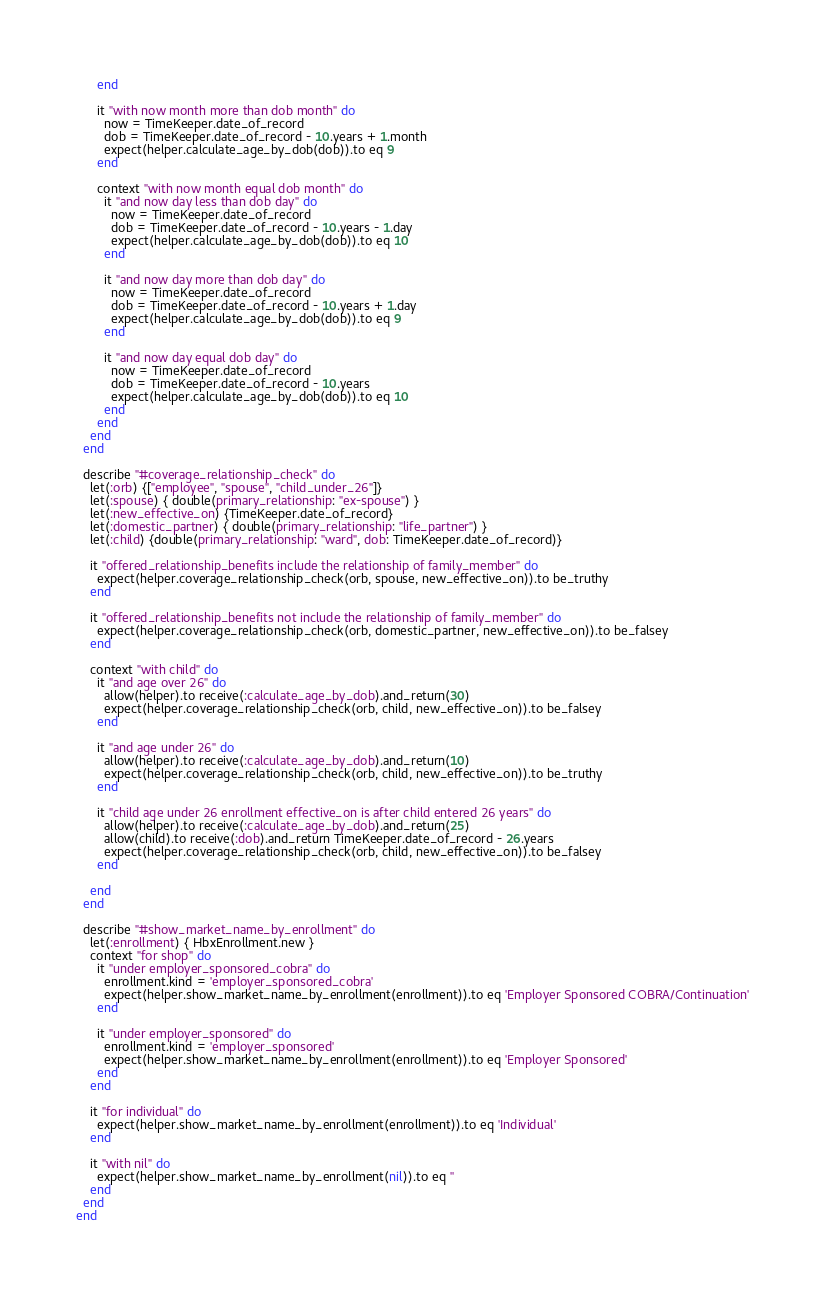<code> <loc_0><loc_0><loc_500><loc_500><_Ruby_>      end

      it "with now month more than dob month" do
        now = TimeKeeper.date_of_record
        dob = TimeKeeper.date_of_record - 10.years + 1.month
        expect(helper.calculate_age_by_dob(dob)).to eq 9
      end

      context "with now month equal dob month" do
        it "and now day less than dob day" do
          now = TimeKeeper.date_of_record
          dob = TimeKeeper.date_of_record - 10.years - 1.day
          expect(helper.calculate_age_by_dob(dob)).to eq 10
        end

        it "and now day more than dob day" do
          now = TimeKeeper.date_of_record
          dob = TimeKeeper.date_of_record - 10.years + 1.day
          expect(helper.calculate_age_by_dob(dob)).to eq 9
        end

        it "and now day equal dob day" do
          now = TimeKeeper.date_of_record
          dob = TimeKeeper.date_of_record - 10.years
          expect(helper.calculate_age_by_dob(dob)).to eq 10
        end
      end
    end
  end

  describe "#coverage_relationship_check" do
    let(:orb) {["employee", "spouse", "child_under_26"]}
    let(:spouse) { double(primary_relationship: "ex-spouse") }
    let(:new_effective_on) {TimeKeeper.date_of_record}
    let(:domestic_partner) { double(primary_relationship: "life_partner") }
    let(:child) {double(primary_relationship: "ward", dob: TimeKeeper.date_of_record)}

    it "offered_relationship_benefits include the relationship of family_member" do
      expect(helper.coverage_relationship_check(orb, spouse, new_effective_on)).to be_truthy
    end

    it "offered_relationship_benefits not include the relationship of family_member" do
      expect(helper.coverage_relationship_check(orb, domestic_partner, new_effective_on)).to be_falsey
    end

    context "with child" do
      it "and age over 26" do
        allow(helper).to receive(:calculate_age_by_dob).and_return(30)
        expect(helper.coverage_relationship_check(orb, child, new_effective_on)).to be_falsey
      end

      it "and age under 26" do
        allow(helper).to receive(:calculate_age_by_dob).and_return(10)
        expect(helper.coverage_relationship_check(orb, child, new_effective_on)).to be_truthy
      end

      it "child age under 26 enrollment effective_on is after child entered 26 years" do
        allow(helper).to receive(:calculate_age_by_dob).and_return(25)
        allow(child).to receive(:dob).and_return TimeKeeper.date_of_record - 26.years
        expect(helper.coverage_relationship_check(orb, child, new_effective_on)).to be_falsey
      end

    end
  end

  describe "#show_market_name_by_enrollment" do
    let(:enrollment) { HbxEnrollment.new }
    context "for shop" do
      it "under employer_sponsored_cobra" do
        enrollment.kind = 'employer_sponsored_cobra'
        expect(helper.show_market_name_by_enrollment(enrollment)).to eq 'Employer Sponsored COBRA/Continuation'
      end

      it "under employer_sponsored" do
        enrollment.kind = 'employer_sponsored'
        expect(helper.show_market_name_by_enrollment(enrollment)).to eq 'Employer Sponsored'
      end
    end

    it "for individual" do
      expect(helper.show_market_name_by_enrollment(enrollment)).to eq 'Individual'
    end

    it "with nil" do
      expect(helper.show_market_name_by_enrollment(nil)).to eq ''
    end
  end
end
</code> 